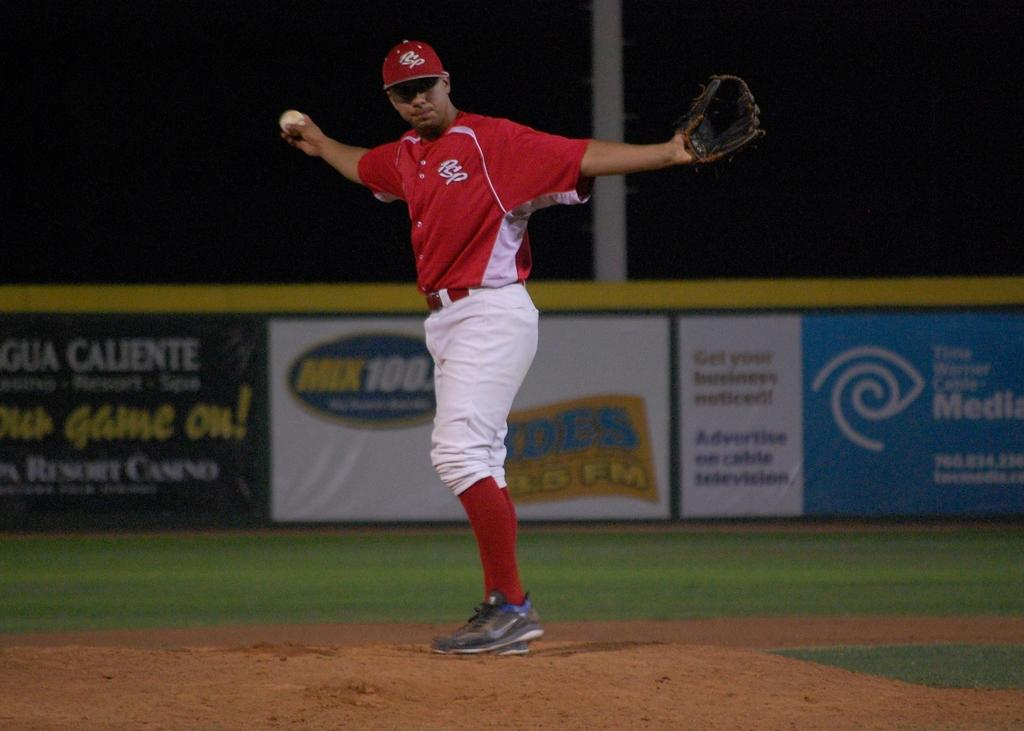Provide a one-sentence caption for the provided image. The PSP pitcher is standing on the mound with his arms stretched out. 